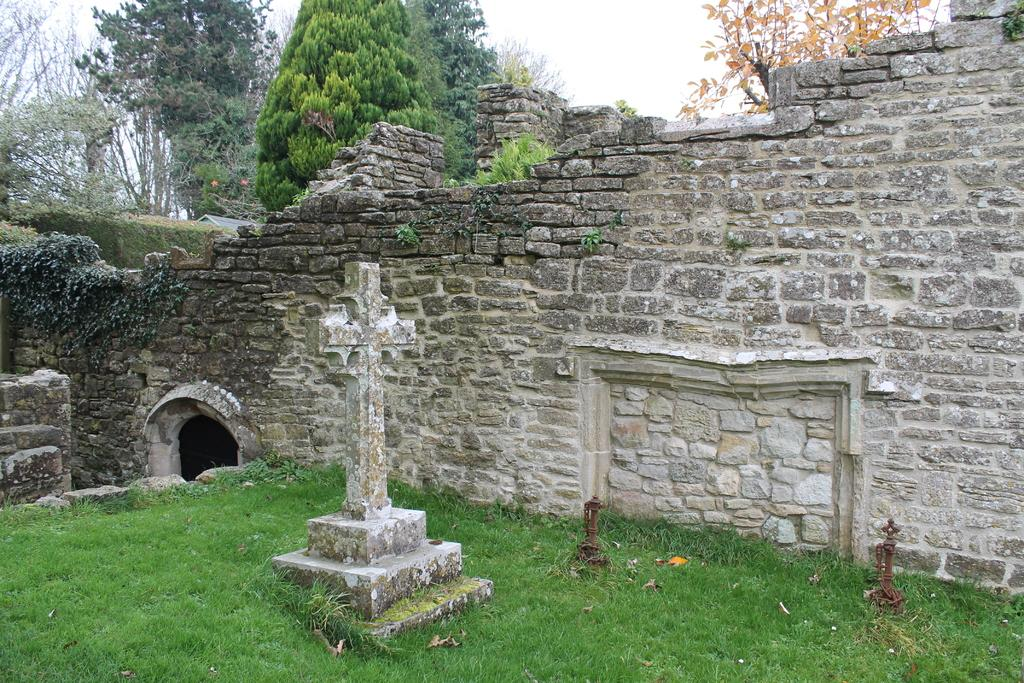What religious symbol is present in the image? There is a cross in the image. What type of vegetation is visible in the image? There is grass in the image. What architectural feature is present in the image? There is a wall in the image. What type of natural environment is visible in the image? There are trees in the image. What part of the natural environment is visible in the background of the image? The sky is visible in the background of the image. How many owls are sitting on the cross in the image? There are no owls present in the image. What is the size of the trees in the image? The size of the trees cannot be determined from the image alone. Are there any horses visible in the image? There are no horses present in the image. 